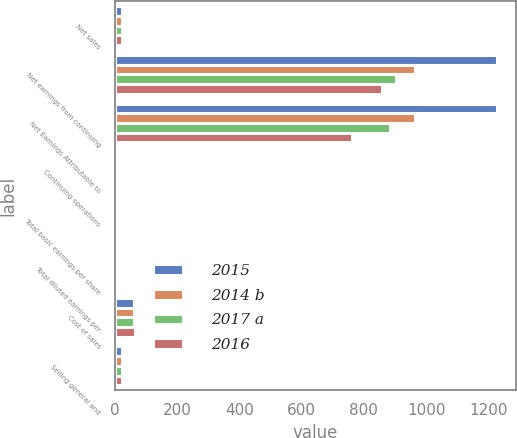Convert chart. <chart><loc_0><loc_0><loc_500><loc_500><stacked_bar_chart><ecel><fcel>Net sales<fcel>Net earnings from continuing<fcel>Net Earnings Attributable to<fcel>Continuing operations<fcel>Total basic earnings per share<fcel>Total diluted earnings per<fcel>Cost of sales<fcel>Selling general and<nl><fcel>2015<fcel>22.95<fcel>1226<fcel>1226<fcel>8.19<fcel>8.19<fcel>8.04<fcel>62.5<fcel>23.4<nl><fcel>2014 b<fcel>22.95<fcel>965<fcel>965<fcel>6.61<fcel>6.61<fcel>6.51<fcel>62.6<fcel>23<nl><fcel>2017 a<fcel>22.95<fcel>904<fcel>884<fcel>6.1<fcel>5.96<fcel>5.79<fcel>63.6<fcel>22.3<nl><fcel>2016<fcel>22.95<fcel>857<fcel>761<fcel>5.49<fcel>4.87<fcel>4.76<fcel>63.8<fcel>22.9<nl></chart> 